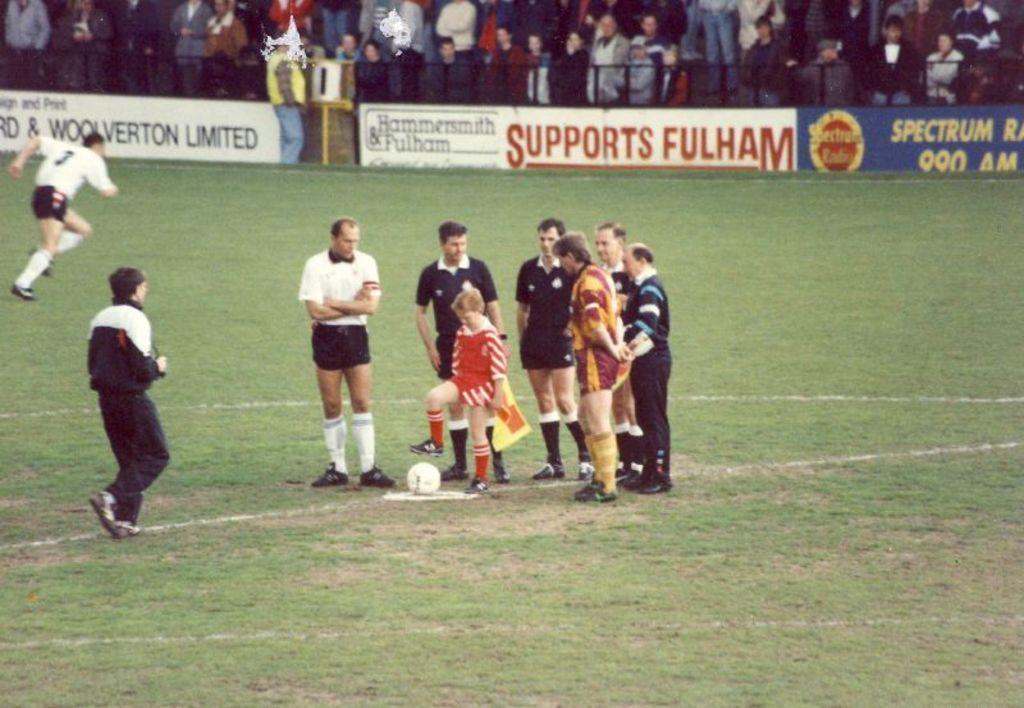Can you describe this image briefly? In this image I can see grass ground and on it I can see white lines, a white colour football and I can see number of people are standing. I can see few of them are wearing white dress and most of them are wearing black. In the background I can see few boards and I can see number of people are standing. I can also see something is written on these boards. 